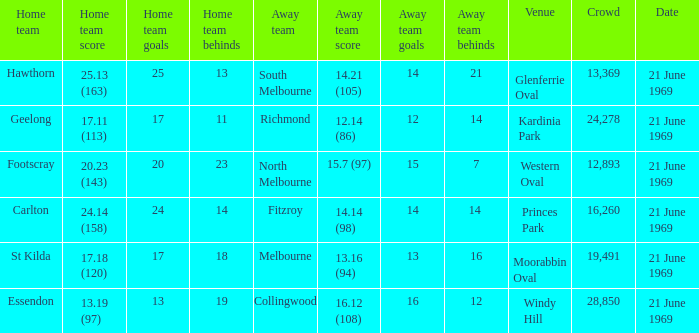When did an away team score 15.7 (97)? 21 June 1969. 